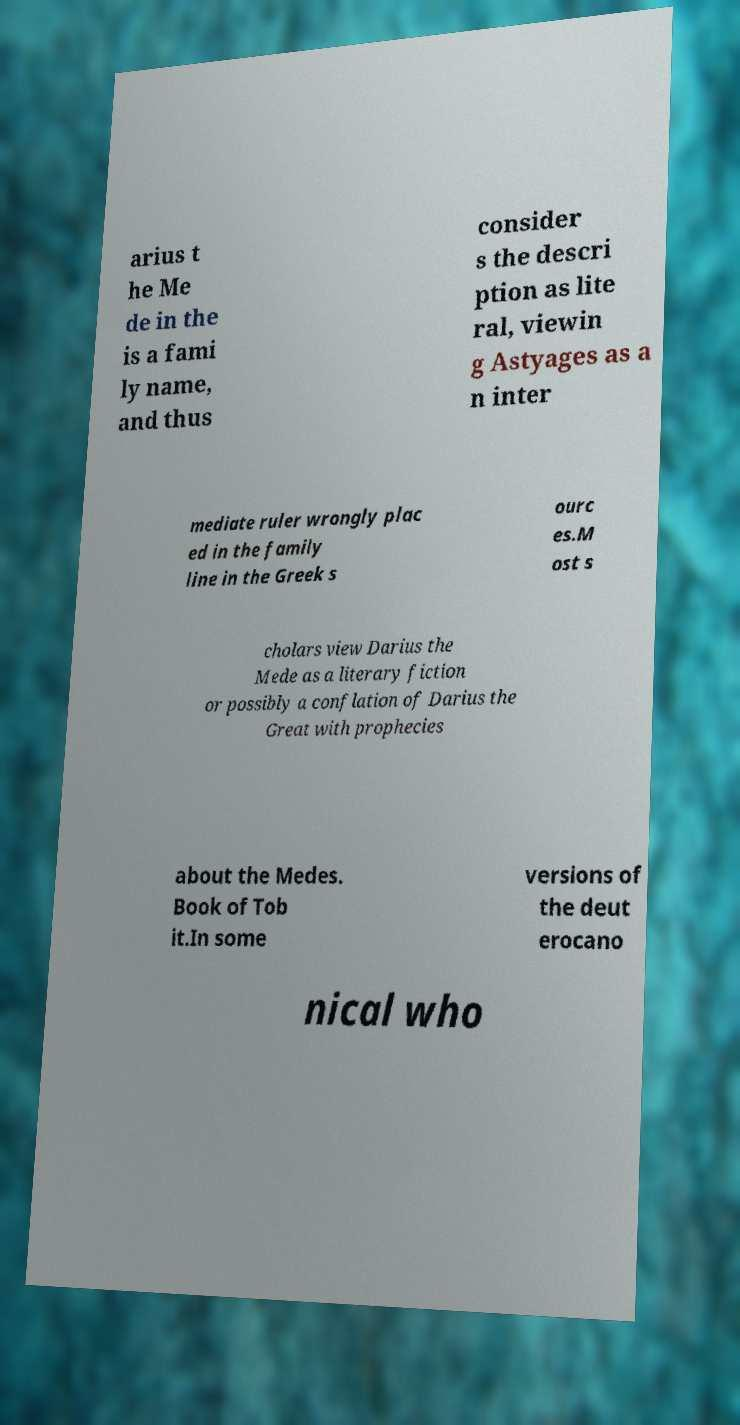For documentation purposes, I need the text within this image transcribed. Could you provide that? arius t he Me de in the is a fami ly name, and thus consider s the descri ption as lite ral, viewin g Astyages as a n inter mediate ruler wrongly plac ed in the family line in the Greek s ourc es.M ost s cholars view Darius the Mede as a literary fiction or possibly a conflation of Darius the Great with prophecies about the Medes. Book of Tob it.In some versions of the deut erocano nical who 